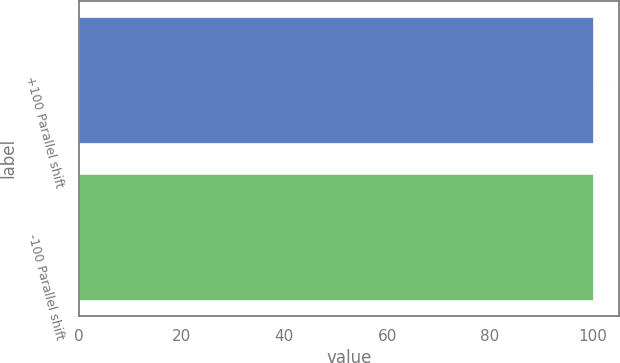Convert chart. <chart><loc_0><loc_0><loc_500><loc_500><bar_chart><fcel>+100 Parallel shift<fcel>-100 Parallel shift<nl><fcel>100<fcel>100.1<nl></chart> 